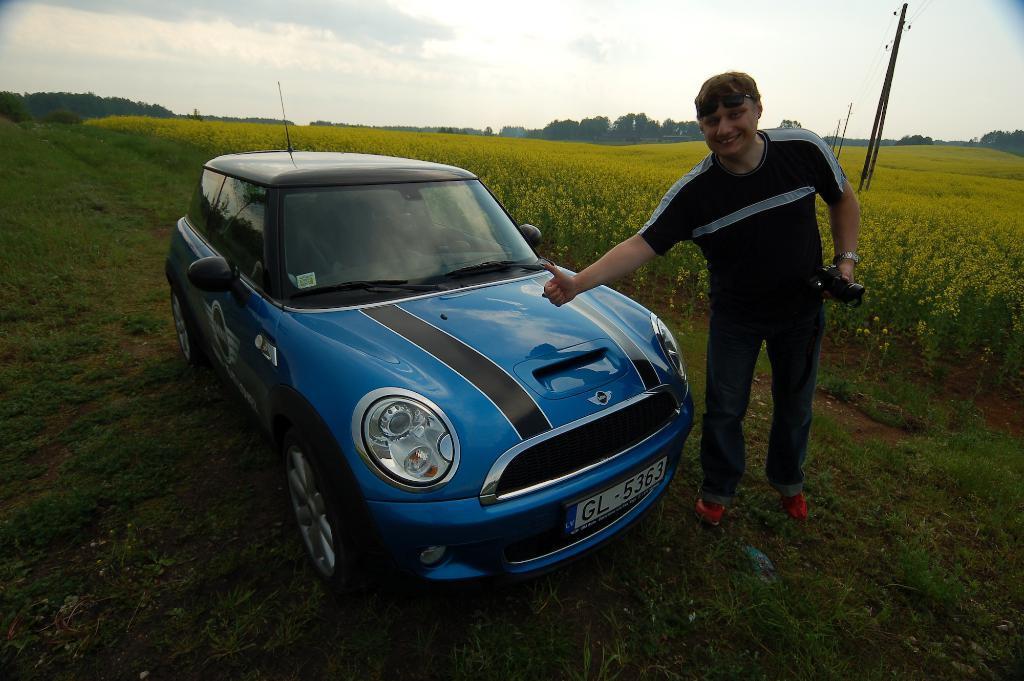How would you summarize this image in a sentence or two? In this image we can see a blue color car and one man is standing. He is wearing black color t-shirt with jeans and holding some thing in his hand. Background of the image field is there. The sky is covered with cloud and electric poles and wires are present. Left side of the image land is covered with grass. 